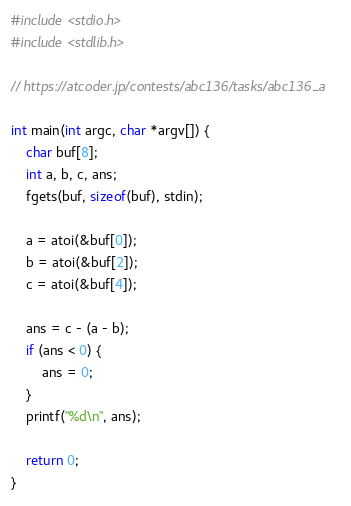Convert code to text. <code><loc_0><loc_0><loc_500><loc_500><_C_>#include <stdio.h>
#include <stdlib.h>

// https://atcoder.jp/contests/abc136/tasks/abc136_a

int main(int argc, char *argv[]) {
    char buf[8];
    int a, b, c, ans;
    fgets(buf, sizeof(buf), stdin);

    a = atoi(&buf[0]);
    b = atoi(&buf[2]);
    c = atoi(&buf[4]);

    ans = c - (a - b);
    if (ans < 0) {
        ans = 0;
    }
    printf("%d\n", ans);

    return 0;
}
</code> 